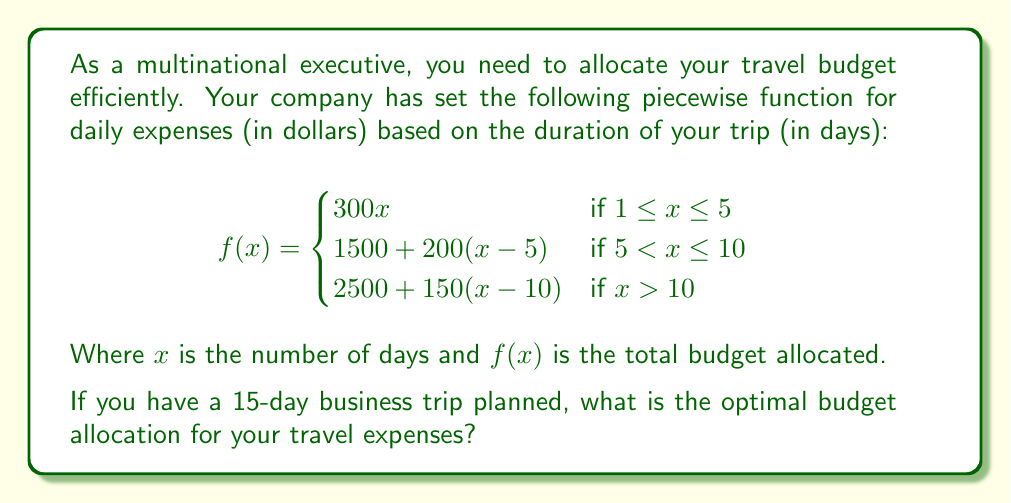Give your solution to this math problem. To solve this problem, we need to use the appropriate piece of the piecewise function since the trip duration is 15 days.

1. First, we identify which part of the function applies:
   Since $x = 15$, and $15 > 10$, we use the third piece of the function.

2. The applicable function is:
   $f(x) = 2500 + 150(x-10)$ for $x > 10$

3. Now, we substitute $x = 15$ into this function:
   $f(15) = 2500 + 150(15-10)$

4. Simplify:
   $f(15) = 2500 + 150(5)$
   $f(15) = 2500 + 750$

5. Calculate the final result:
   $f(15) = 3250$

Therefore, the optimal budget allocation for a 15-day business trip is $3250.
Answer: $3250 